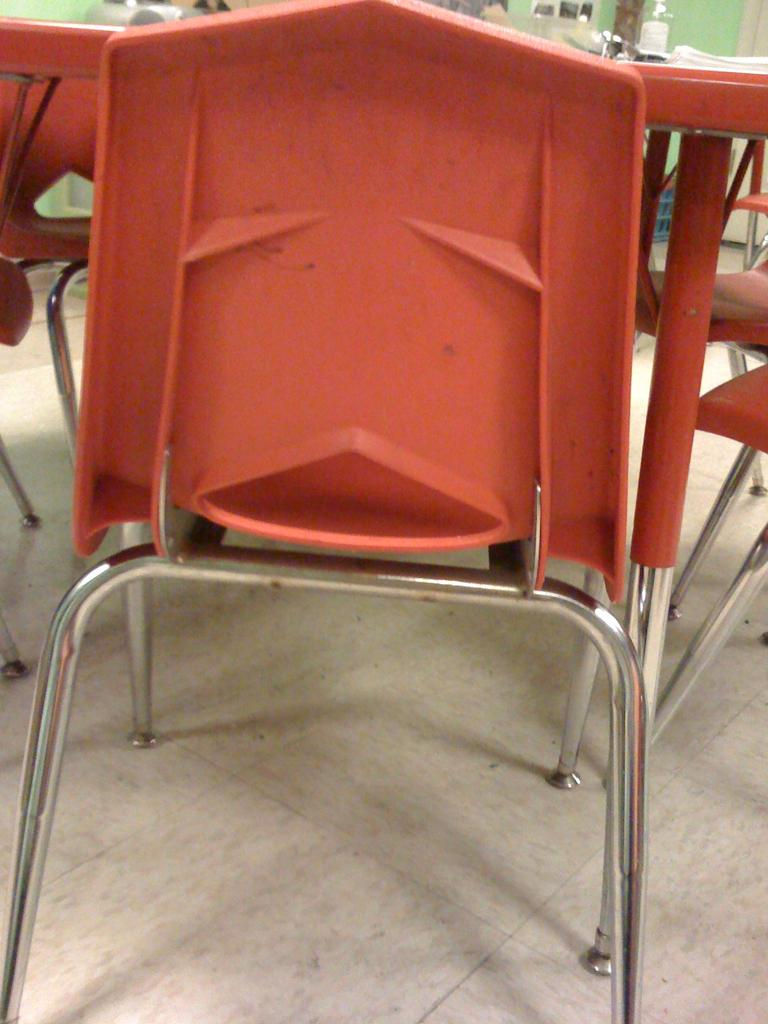What type of furniture is present in the image? There is a group of chairs and a table in the image. Where are the chairs and table located? The chairs and table are placed on the ground. What can be seen in the background of the image? There is a basket and a wall in the background of the image. What type of trousers are being worn by the chairs in the image? Chairs do not wear trousers, as they are inanimate objects. 